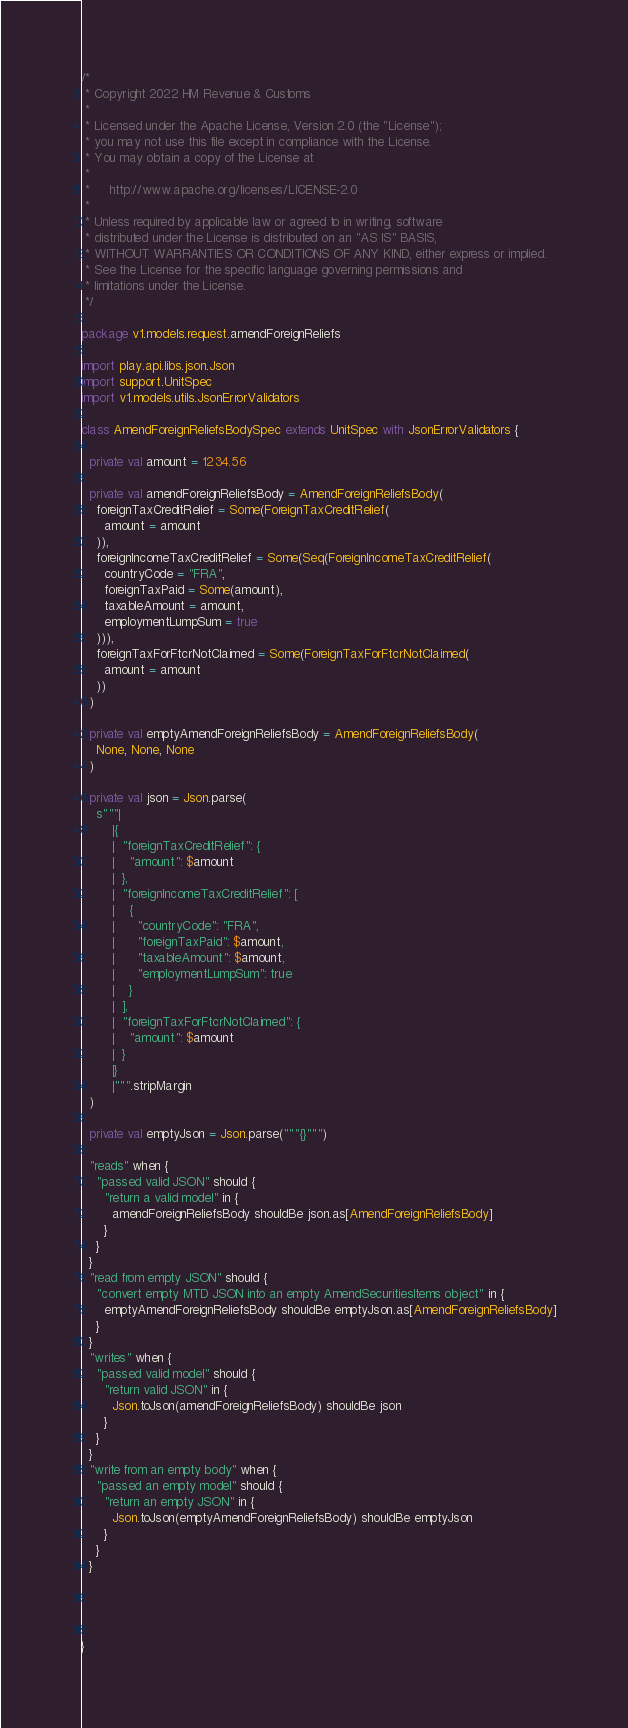<code> <loc_0><loc_0><loc_500><loc_500><_Scala_>/*
 * Copyright 2022 HM Revenue & Customs
 *
 * Licensed under the Apache License, Version 2.0 (the "License");
 * you may not use this file except in compliance with the License.
 * You may obtain a copy of the License at
 *
 *     http://www.apache.org/licenses/LICENSE-2.0
 *
 * Unless required by applicable law or agreed to in writing, software
 * distributed under the License is distributed on an "AS IS" BASIS,
 * WITHOUT WARRANTIES OR CONDITIONS OF ANY KIND, either express or implied.
 * See the License for the specific language governing permissions and
 * limitations under the License.
 */

package v1.models.request.amendForeignReliefs

import play.api.libs.json.Json
import support.UnitSpec
import v1.models.utils.JsonErrorValidators

class AmendForeignReliefsBodySpec extends UnitSpec with JsonErrorValidators {

  private val amount = 1234.56

  private val amendForeignReliefsBody = AmendForeignReliefsBody(
    foreignTaxCreditRelief = Some(ForeignTaxCreditRelief(
      amount = amount
    )),
    foreignIncomeTaxCreditRelief = Some(Seq(ForeignIncomeTaxCreditRelief(
      countryCode = "FRA",
      foreignTaxPaid = Some(amount),
      taxableAmount = amount,
      employmentLumpSum = true
    ))),
    foreignTaxForFtcrNotClaimed = Some(ForeignTaxForFtcrNotClaimed(
      amount = amount
    ))
  )

  private val emptyAmendForeignReliefsBody = AmendForeignReliefsBody(
    None, None, None
  )

  private val json = Json.parse(
    s"""|
        |{
        |  "foreignTaxCreditRelief": {
        |    "amount": $amount
        |  },
        |  "foreignIncomeTaxCreditRelief": [
        |    {
        |      "countryCode": "FRA",
        |      "foreignTaxPaid": $amount,
        |      "taxableAmount": $amount,
        |      "employmentLumpSum": true
        |    }
        |  ],
        |  "foreignTaxForFtcrNotClaimed": {
        |    "amount": $amount
        |  }
        |}
        |""".stripMargin
  )

  private val emptyJson = Json.parse("""{}""")

  "reads" when {
    "passed valid JSON" should {
      "return a valid model" in {
        amendForeignReliefsBody shouldBe json.as[AmendForeignReliefsBody]
      }
    }
  }
  "read from empty JSON" should {
    "convert empty MTD JSON into an empty AmendSecuritiesItems object" in {
      emptyAmendForeignReliefsBody shouldBe emptyJson.as[AmendForeignReliefsBody]
    }
  }
  "writes" when {
    "passed valid model" should {
      "return valid JSON" in {
        Json.toJson(amendForeignReliefsBody) shouldBe json
      }
    }
  }
  "write from an empty body" when {
    "passed an empty model" should {
      "return an empty JSON" in {
        Json.toJson(emptyAmendForeignReliefsBody) shouldBe emptyJson
      }
    }
  }




}</code> 